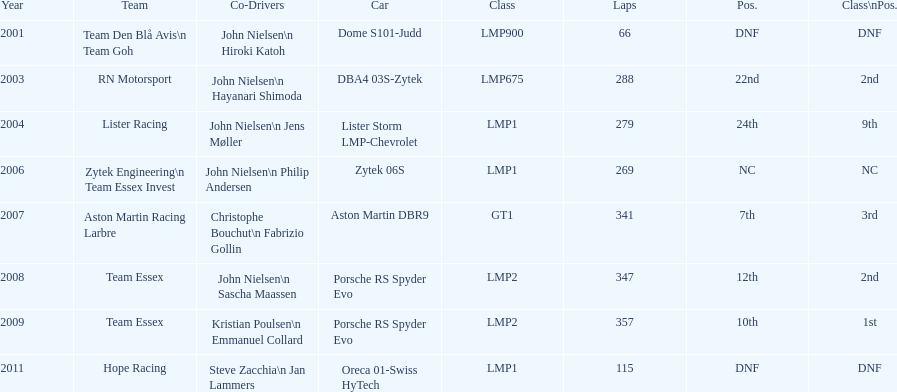In 2008 and another year, when was casper elgaard part of team essex in the 24 hours of le mans? 2009. 